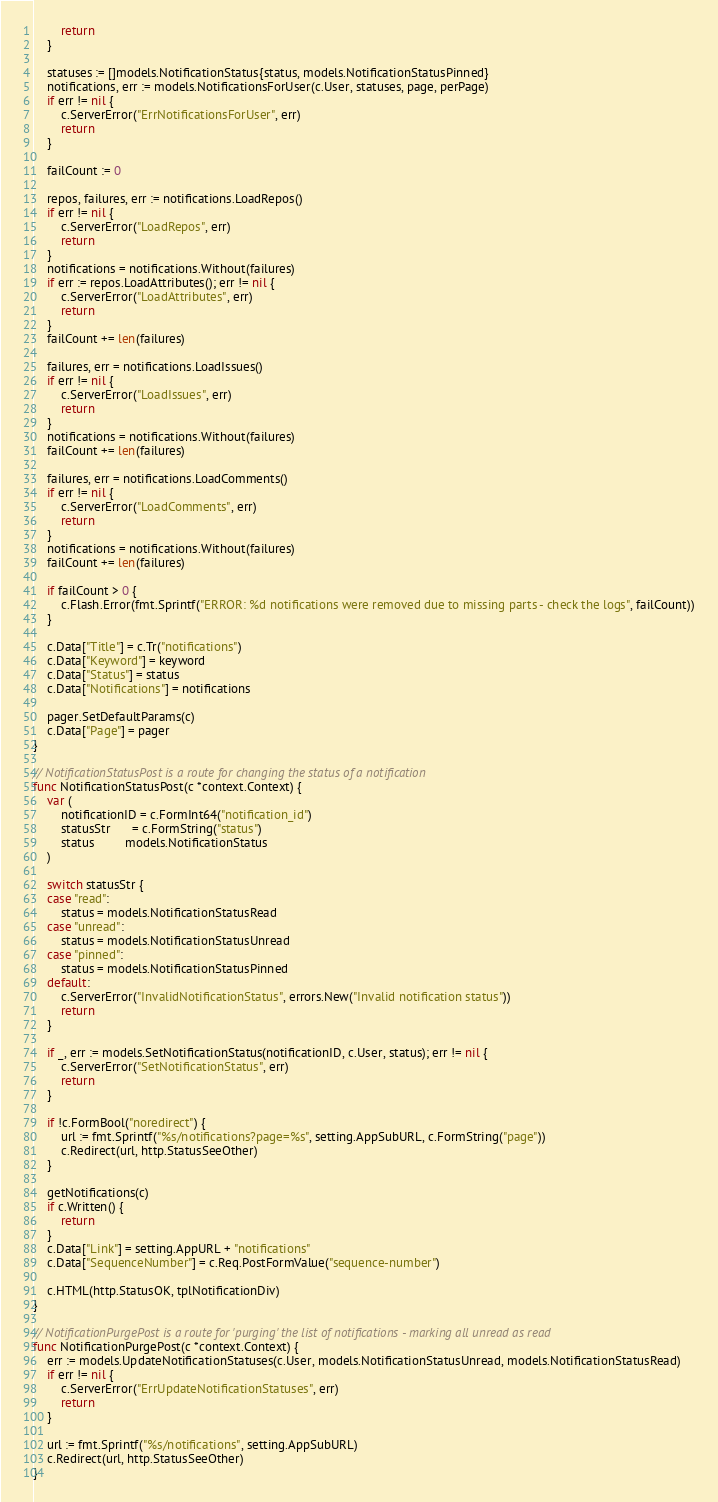<code> <loc_0><loc_0><loc_500><loc_500><_Go_>		return
	}

	statuses := []models.NotificationStatus{status, models.NotificationStatusPinned}
	notifications, err := models.NotificationsForUser(c.User, statuses, page, perPage)
	if err != nil {
		c.ServerError("ErrNotificationsForUser", err)
		return
	}

	failCount := 0

	repos, failures, err := notifications.LoadRepos()
	if err != nil {
		c.ServerError("LoadRepos", err)
		return
	}
	notifications = notifications.Without(failures)
	if err := repos.LoadAttributes(); err != nil {
		c.ServerError("LoadAttributes", err)
		return
	}
	failCount += len(failures)

	failures, err = notifications.LoadIssues()
	if err != nil {
		c.ServerError("LoadIssues", err)
		return
	}
	notifications = notifications.Without(failures)
	failCount += len(failures)

	failures, err = notifications.LoadComments()
	if err != nil {
		c.ServerError("LoadComments", err)
		return
	}
	notifications = notifications.Without(failures)
	failCount += len(failures)

	if failCount > 0 {
		c.Flash.Error(fmt.Sprintf("ERROR: %d notifications were removed due to missing parts - check the logs", failCount))
	}

	c.Data["Title"] = c.Tr("notifications")
	c.Data["Keyword"] = keyword
	c.Data["Status"] = status
	c.Data["Notifications"] = notifications

	pager.SetDefaultParams(c)
	c.Data["Page"] = pager
}

// NotificationStatusPost is a route for changing the status of a notification
func NotificationStatusPost(c *context.Context) {
	var (
		notificationID = c.FormInt64("notification_id")
		statusStr      = c.FormString("status")
		status         models.NotificationStatus
	)

	switch statusStr {
	case "read":
		status = models.NotificationStatusRead
	case "unread":
		status = models.NotificationStatusUnread
	case "pinned":
		status = models.NotificationStatusPinned
	default:
		c.ServerError("InvalidNotificationStatus", errors.New("Invalid notification status"))
		return
	}

	if _, err := models.SetNotificationStatus(notificationID, c.User, status); err != nil {
		c.ServerError("SetNotificationStatus", err)
		return
	}

	if !c.FormBool("noredirect") {
		url := fmt.Sprintf("%s/notifications?page=%s", setting.AppSubURL, c.FormString("page"))
		c.Redirect(url, http.StatusSeeOther)
	}

	getNotifications(c)
	if c.Written() {
		return
	}
	c.Data["Link"] = setting.AppURL + "notifications"
	c.Data["SequenceNumber"] = c.Req.PostFormValue("sequence-number")

	c.HTML(http.StatusOK, tplNotificationDiv)
}

// NotificationPurgePost is a route for 'purging' the list of notifications - marking all unread as read
func NotificationPurgePost(c *context.Context) {
	err := models.UpdateNotificationStatuses(c.User, models.NotificationStatusUnread, models.NotificationStatusRead)
	if err != nil {
		c.ServerError("ErrUpdateNotificationStatuses", err)
		return
	}

	url := fmt.Sprintf("%s/notifications", setting.AppSubURL)
	c.Redirect(url, http.StatusSeeOther)
}
</code> 